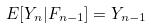<formula> <loc_0><loc_0><loc_500><loc_500>E [ Y _ { n } | F _ { n - 1 } ] = Y _ { n - 1 }</formula> 